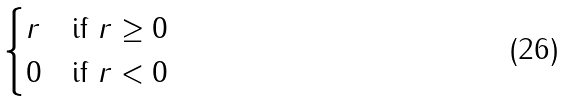Convert formula to latex. <formula><loc_0><loc_0><loc_500><loc_500>\begin{cases} r & \text {if $r\geq 0$} \\ 0 & \text {if $r<0$} \end{cases}</formula> 